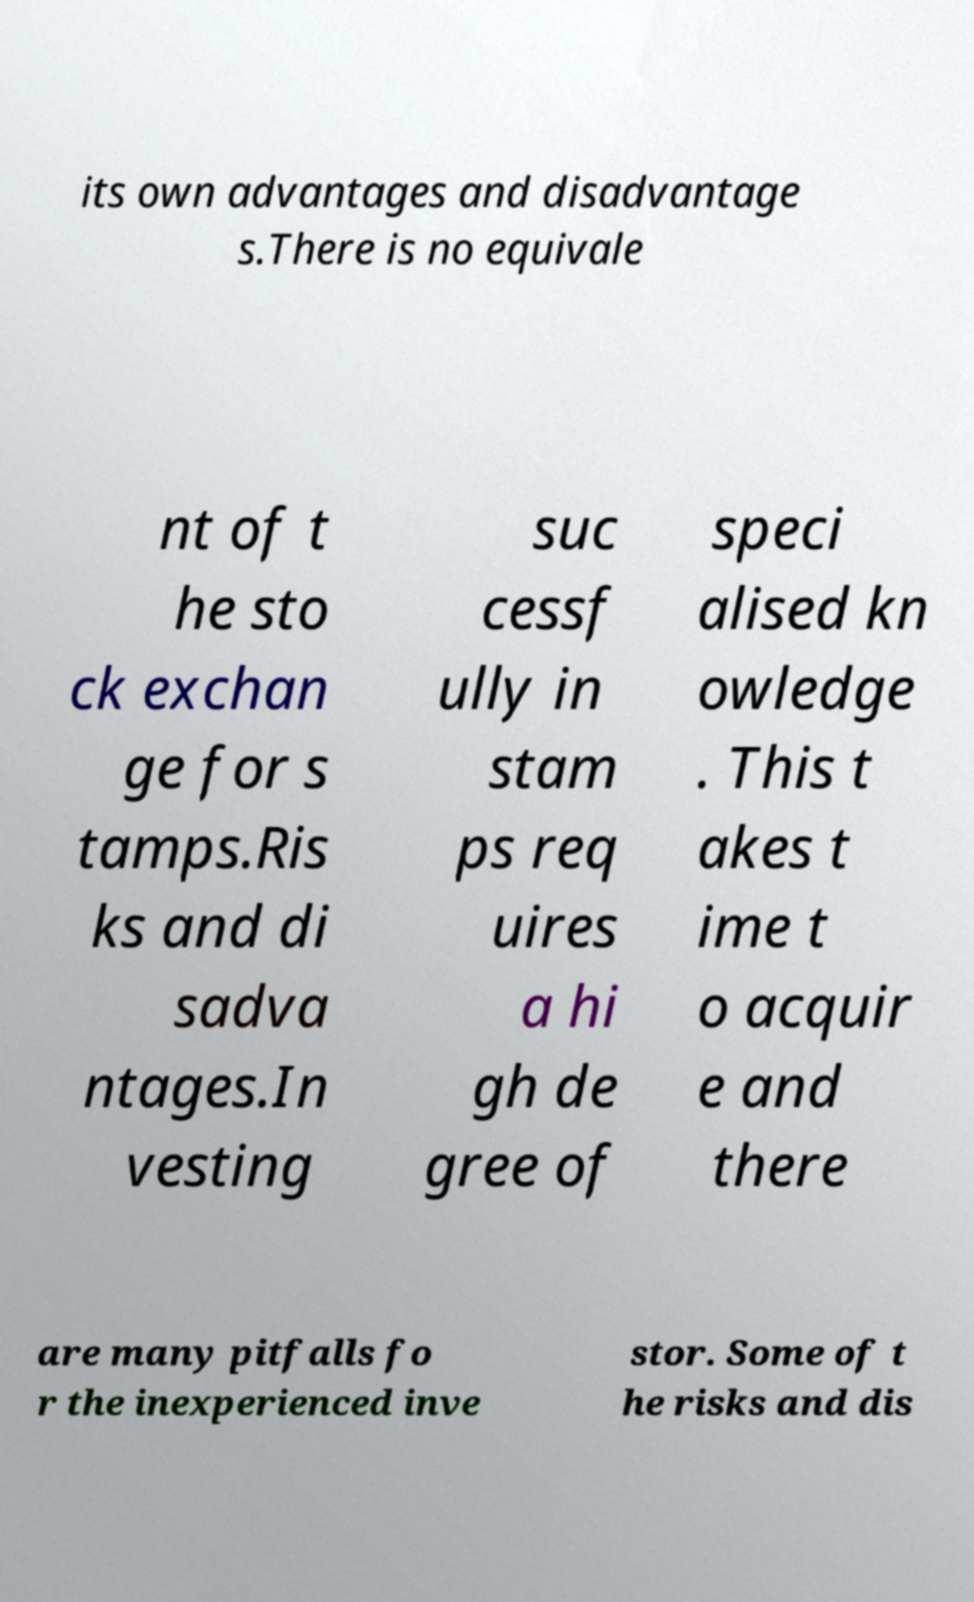Please identify and transcribe the text found in this image. its own advantages and disadvantage s.There is no equivale nt of t he sto ck exchan ge for s tamps.Ris ks and di sadva ntages.In vesting suc cessf ully in stam ps req uires a hi gh de gree of speci alised kn owledge . This t akes t ime t o acquir e and there are many pitfalls fo r the inexperienced inve stor. Some of t he risks and dis 